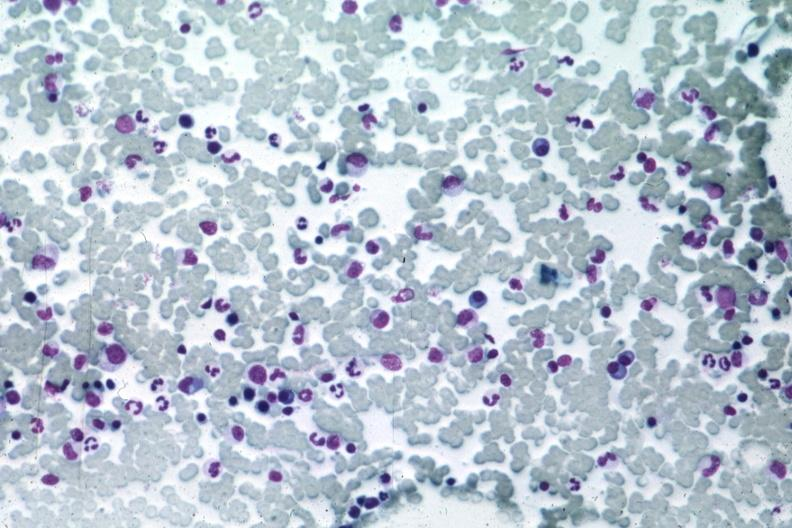what is present?
Answer the question using a single word or phrase. Multiple myeloma 